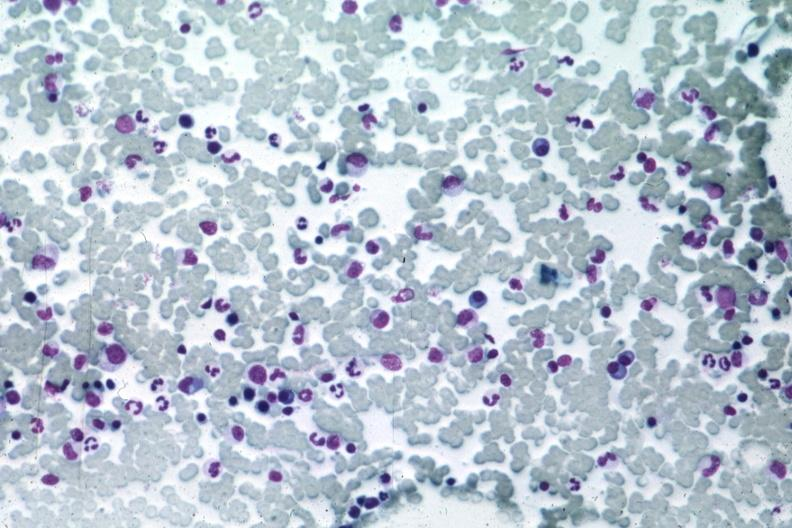what is present?
Answer the question using a single word or phrase. Multiple myeloma 